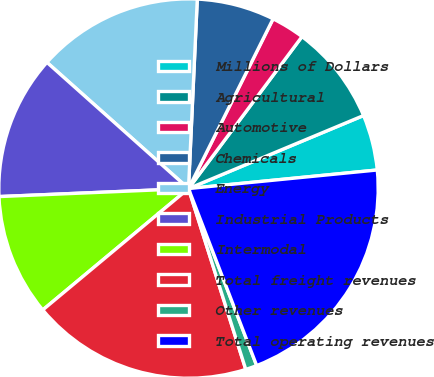<chart> <loc_0><loc_0><loc_500><loc_500><pie_chart><fcel>Millions of Dollars<fcel>Agricultural<fcel>Automotive<fcel>Chemicals<fcel>Energy<fcel>Industrial Products<fcel>Intermodal<fcel>Total freight revenues<fcel>Other revenues<fcel>Total operating revenues<nl><fcel>4.73%<fcel>8.5%<fcel>2.85%<fcel>6.62%<fcel>14.15%<fcel>12.26%<fcel>10.38%<fcel>18.83%<fcel>0.97%<fcel>20.71%<nl></chart> 